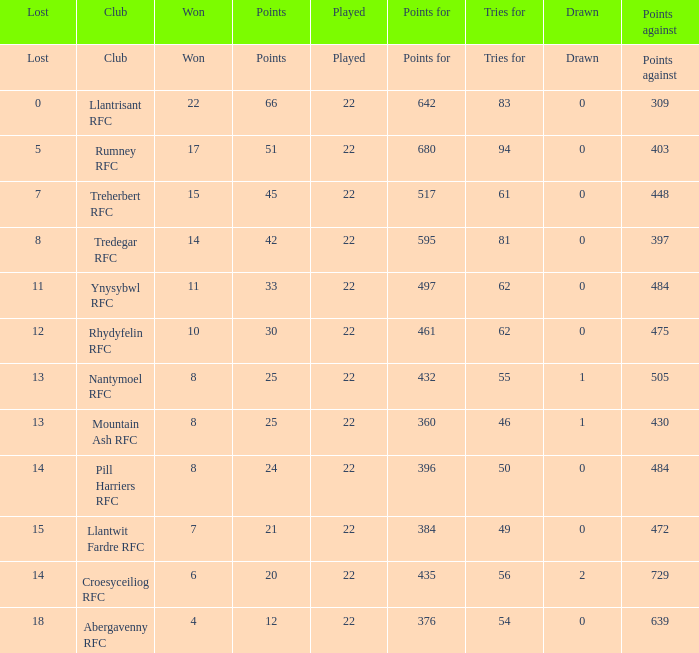For teams that won exactly 15, how many points were scored? 45.0. 